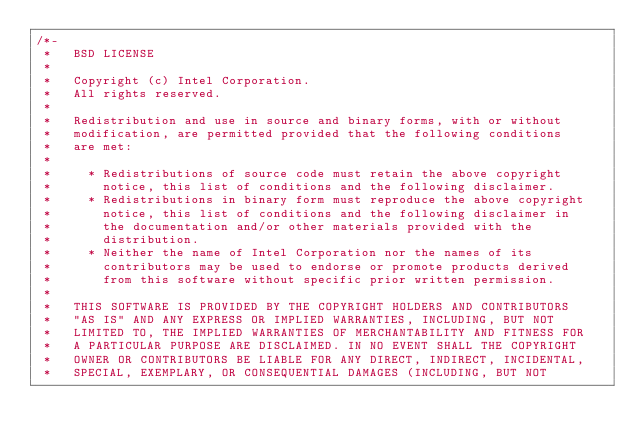<code> <loc_0><loc_0><loc_500><loc_500><_C_>/*-
 *   BSD LICENSE
 *
 *   Copyright (c) Intel Corporation.
 *   All rights reserved.
 *
 *   Redistribution and use in source and binary forms, with or without
 *   modification, are permitted provided that the following conditions
 *   are met:
 *
 *     * Redistributions of source code must retain the above copyright
 *       notice, this list of conditions and the following disclaimer.
 *     * Redistributions in binary form must reproduce the above copyright
 *       notice, this list of conditions and the following disclaimer in
 *       the documentation and/or other materials provided with the
 *       distribution.
 *     * Neither the name of Intel Corporation nor the names of its
 *       contributors may be used to endorse or promote products derived
 *       from this software without specific prior written permission.
 *
 *   THIS SOFTWARE IS PROVIDED BY THE COPYRIGHT HOLDERS AND CONTRIBUTORS
 *   "AS IS" AND ANY EXPRESS OR IMPLIED WARRANTIES, INCLUDING, BUT NOT
 *   LIMITED TO, THE IMPLIED WARRANTIES OF MERCHANTABILITY AND FITNESS FOR
 *   A PARTICULAR PURPOSE ARE DISCLAIMED. IN NO EVENT SHALL THE COPYRIGHT
 *   OWNER OR CONTRIBUTORS BE LIABLE FOR ANY DIRECT, INDIRECT, INCIDENTAL,
 *   SPECIAL, EXEMPLARY, OR CONSEQUENTIAL DAMAGES (INCLUDING, BUT NOT</code> 